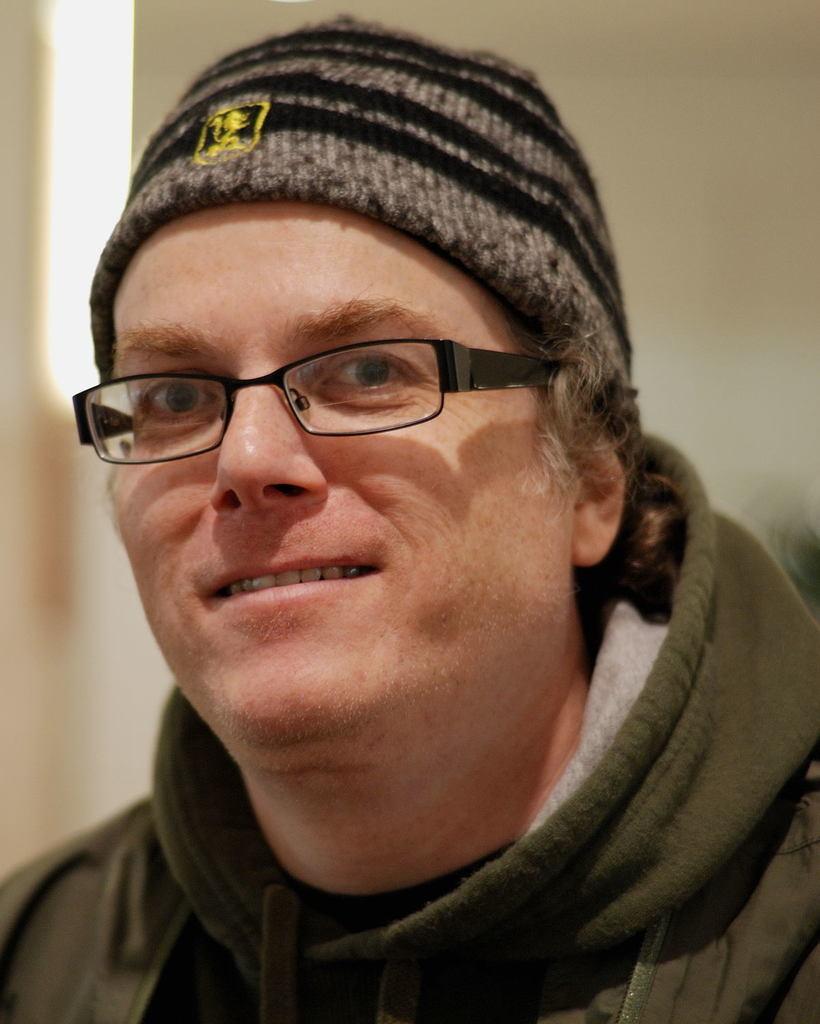Can you describe this image briefly? In this picture there is a man with green jacket. At the back it looks like a wall. 